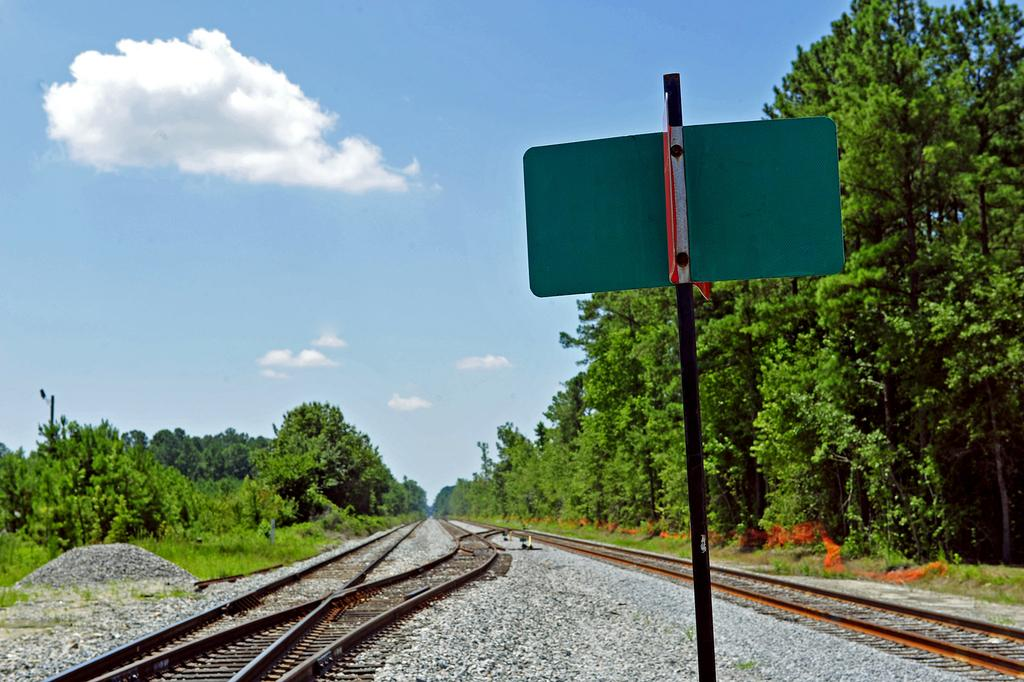What is the main object in the image? There is a board in the image. What can be seen near the board? There are railway tracks in the image. What is visible in the background of the image? There are trees and sky visible in the background of the image. What type of ground surface is present at the bottom of the image? There are stones at the bottom of the image. How many dimes are scattered on the board in the image? There are no dimes present on the board in the image. What type of fold can be seen on the board in the image? The board in the image does not have any folds. 